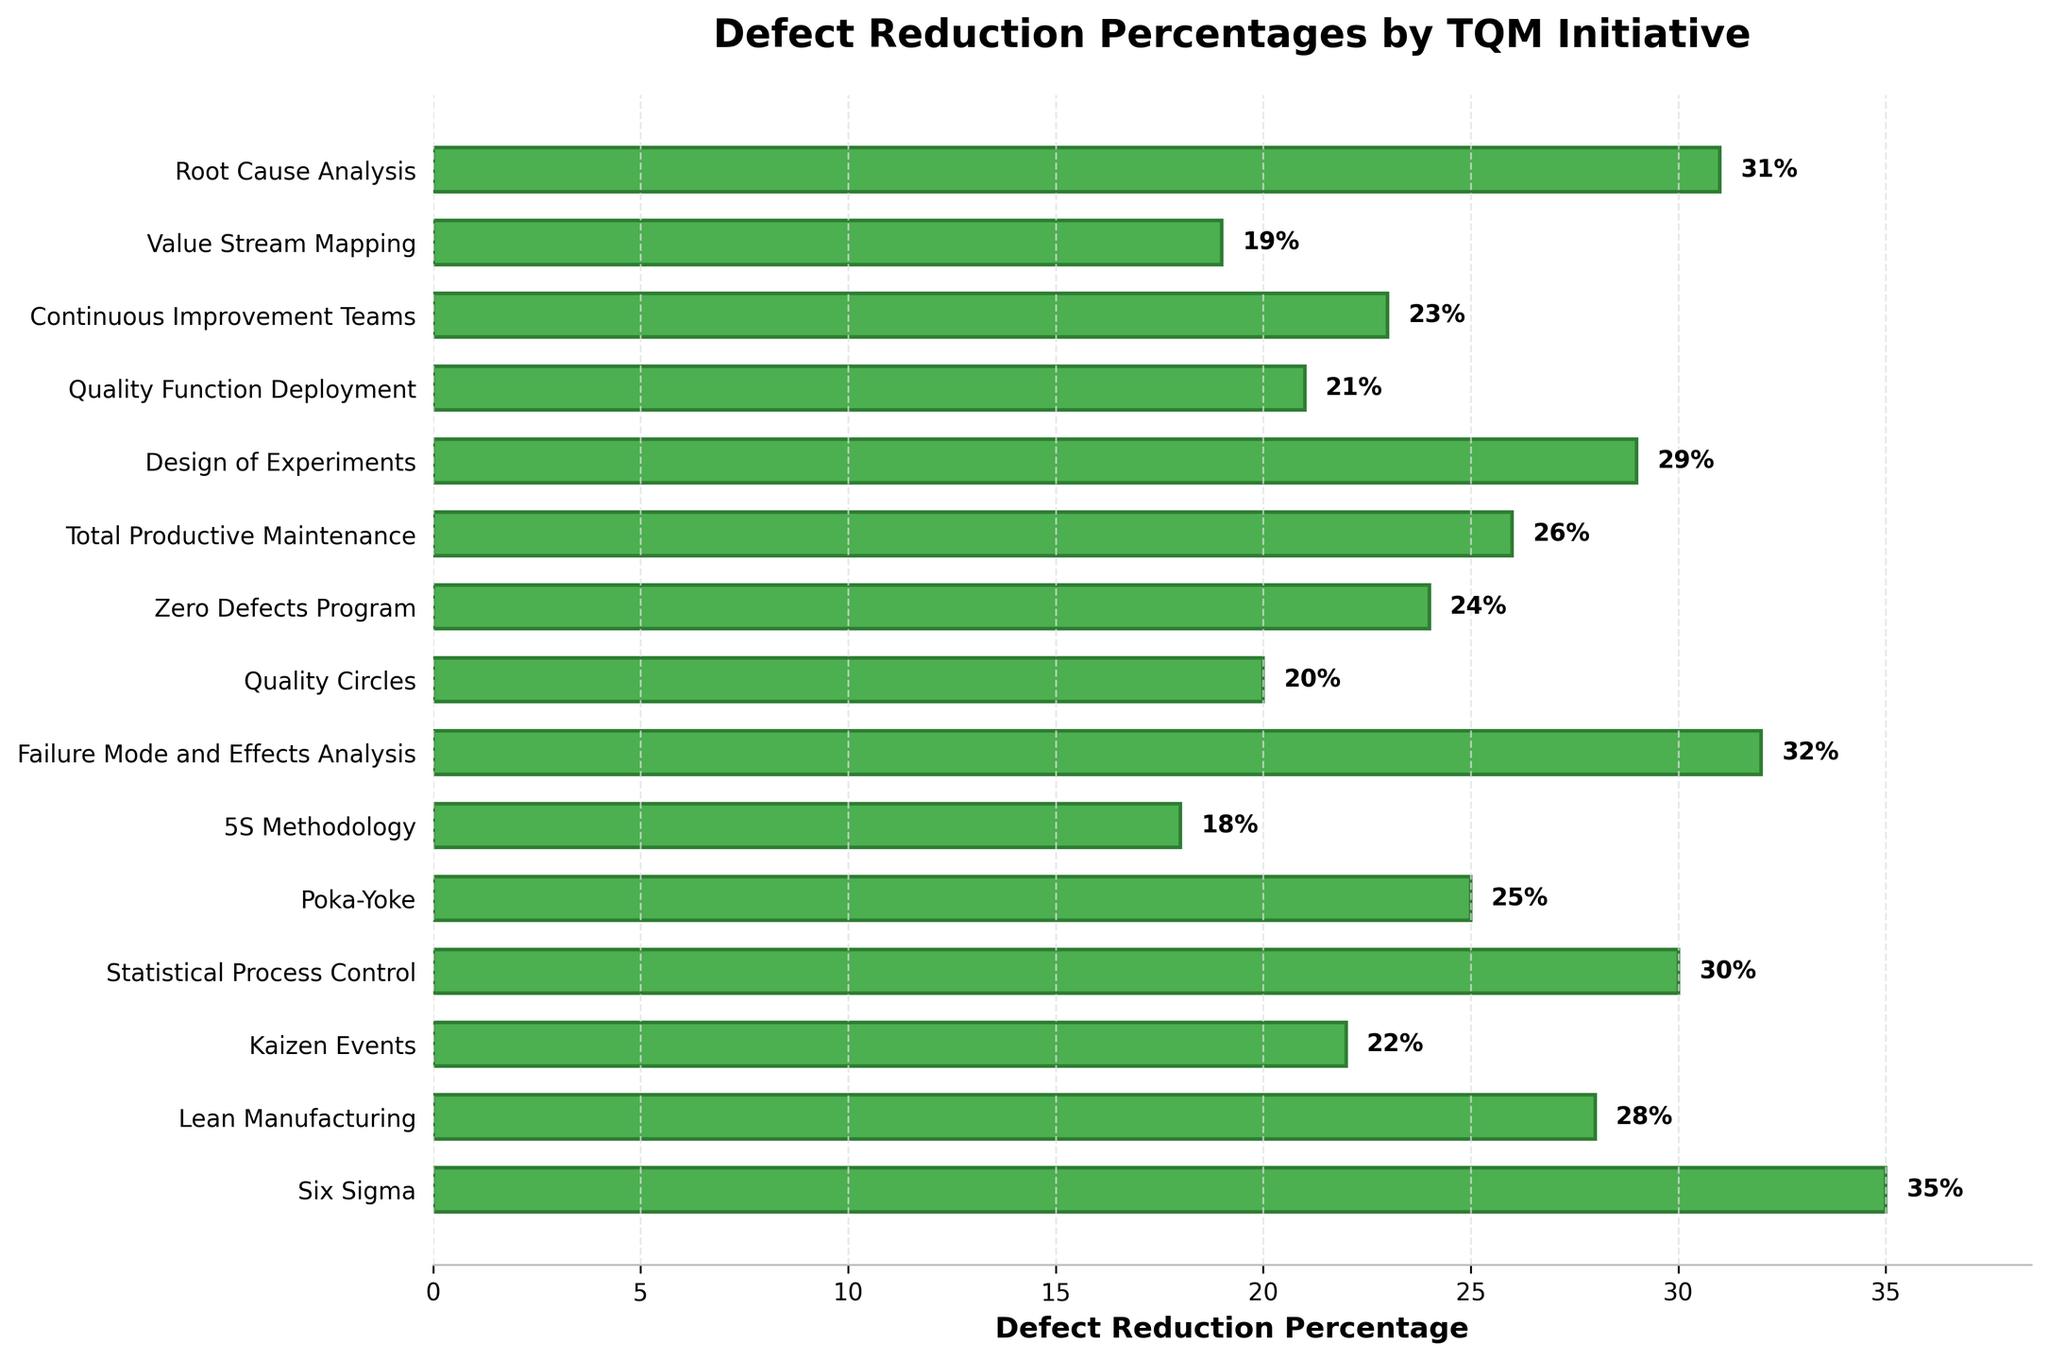What is the initiative with the highest defect reduction percentage? The highest bar indicates the initiative with the highest defect reduction percentage. In the plot, the tallest bar reaches 35%, which belongs to Six Sigma.
Answer: Six Sigma Which initiatives have a defect reduction percentage greater than 30%? Identify the bars that extend beyond the 30% mark. In the figure, the initiatives that exceed this threshold are Six Sigma (35%), Statistical Process Control (30%), Failure Mode and Effects Analysis (32%), and Root Cause Analysis (31%).
Answer: Six Sigma, Statistical Process Control, Failure Mode and Effects Analysis, Root Cause Analysis How much higher is the defect reduction percentage of Six Sigma compared to 5S Methodology? Subtract the defect reduction percentage of 5S Methodology (18%) from that of Six Sigma (35%). Calculation: 35% - 18% = 17%.
Answer: 17% What is the average defect reduction percentage of Lean Manufacturing, Statistical Process Control, and Design of Experiments? Sum the defect reduction percentages of Lean Manufacturing (28%), Statistical Process Control (30%), and Design of Experiments (29%), and then divide by 3. Calculation: (28% + 30% + 29%) / 3 = 29%.
Answer: 29% Which initiatives have defect reduction percentages between 20% and 25%? Identify the bars whose values fall within the range of 20% to 25%. In the figure, the initiatives are Kaizen Events (22%), Quality Circles (20%), Zero Defects Program (24%), Continuous Improvement Teams (23%), and Value Stream Mapping (19%). Remove those not in range.
Answer: Kaizen Events, Zero Defects Program, Continuous Improvement Teams Which initiative has the median defect reduction percentage? First, list all defect reduction percentages in ascending order: 18, 19, 20, 21, 22, 23, 24, 25, 26, 28, 29, 30, 31, 32, 35. Since there are 15 data points, the median is the 8th value. Therefore, the median defect reduction percentage is 24%, corresponding to the Zero Defects Program.
Answer: Zero Defects Program What is the total defect reduction percentage of the top three initiatives? Sum the defect reduction percentages of the top three initiatives: Six Sigma (35%), Failure Mode and Effects Analysis (32%), and Root Cause Analysis (31%). Calculation: 35% + 32% + 31% = 98%.
Answer: 98% Which initiative has the defect reduction percentage closest to the average of all initiatives? First, find the average defect reduction percentage of the entire dataset. Sum all the percentages (you can calculate or use the plot data) and divide by the number of initiatives: (35+28+22+30+25+18+32+20+24+26+29+21+23+19+31)/15 = 26.6%. Identify the bar closest to this value, which is Total Productive Maintenance at 26%.
Answer: Total Productive Maintenance How many initiatives have defect reduction percentages less than the average percentage of the three top-performing initiatives? First compute the average of the top three performing initiatives: (35% + 32% + 31%) / 3 = 32.67%. Count the bars with percentages less than this value. All initiatives except Six Sigma, Failure Mode and Effects Analysis, and Root Cause Analysis fit this criterion. Hence, there are 12 initiatives that meet the condition.
Answer: 12 